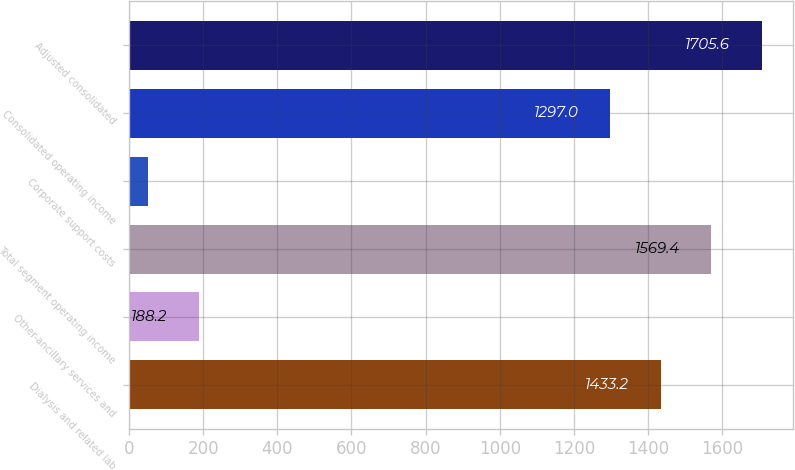<chart> <loc_0><loc_0><loc_500><loc_500><bar_chart><fcel>Dialysis and related lab<fcel>Other-ancillary services and<fcel>Total segment operating income<fcel>Corporate support costs<fcel>Consolidated operating income<fcel>Adjusted consolidated<nl><fcel>1433.2<fcel>188.2<fcel>1569.4<fcel>52<fcel>1297<fcel>1705.6<nl></chart> 